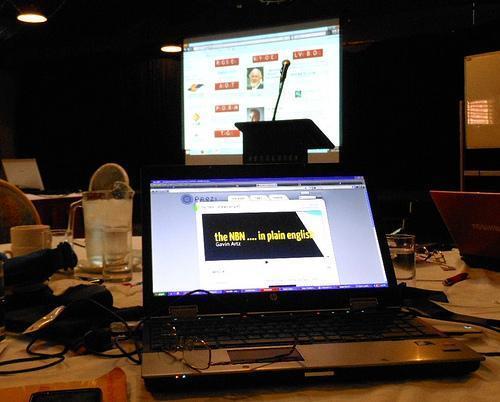How many computers are by a glass of water?
Give a very brief answer. 1. 